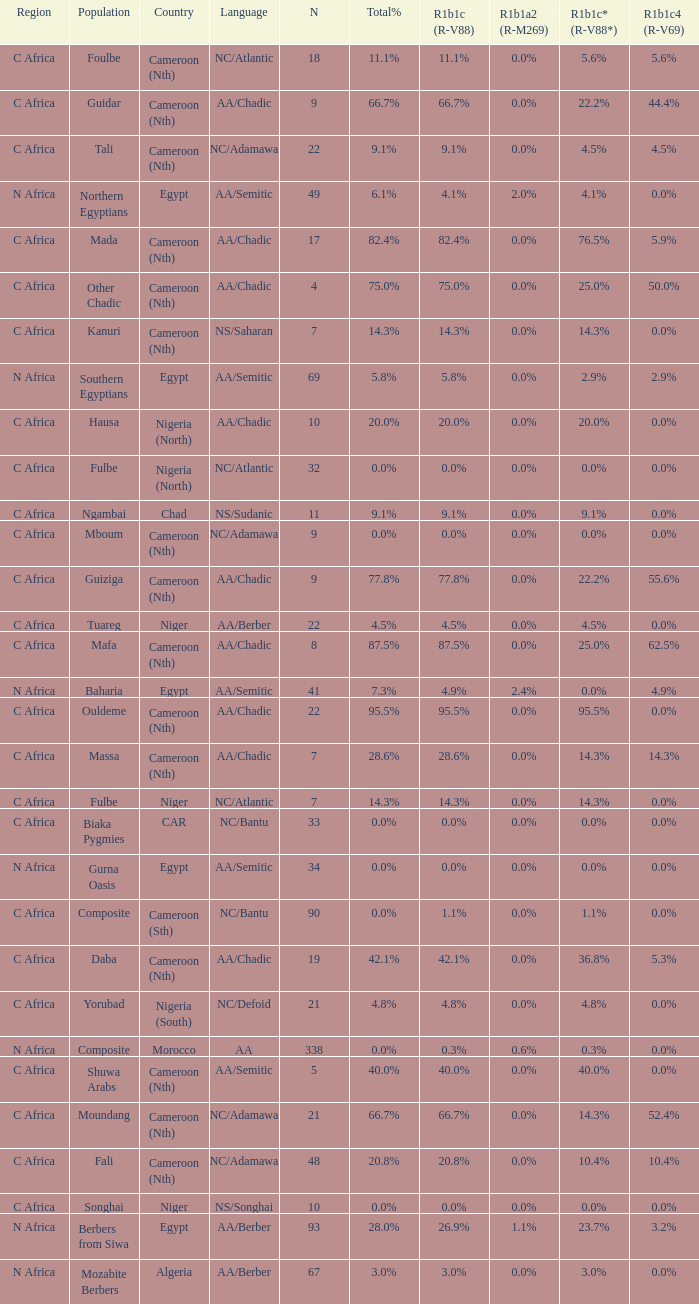How many n are listed for 0.6% r1b1a2 (r-m269)? 1.0. 